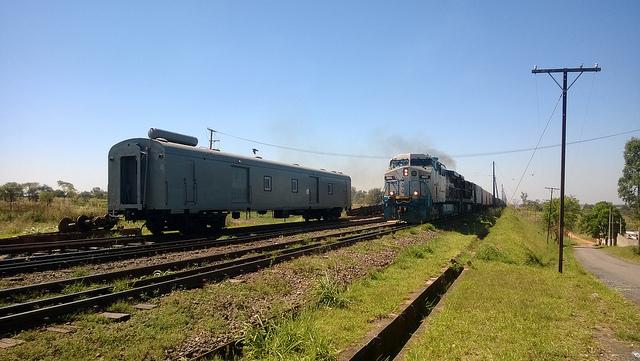How many train tracks are there?
Answer briefly. 2. What is the train blowing out?
Concise answer only. Smoke. How many trains are moving?
Quick response, please. 1. What powers this engine?
Give a very brief answer. Coal. Are these freight trains?
Keep it brief. Yes. What is the weather?
Write a very short answer. Sunny. 